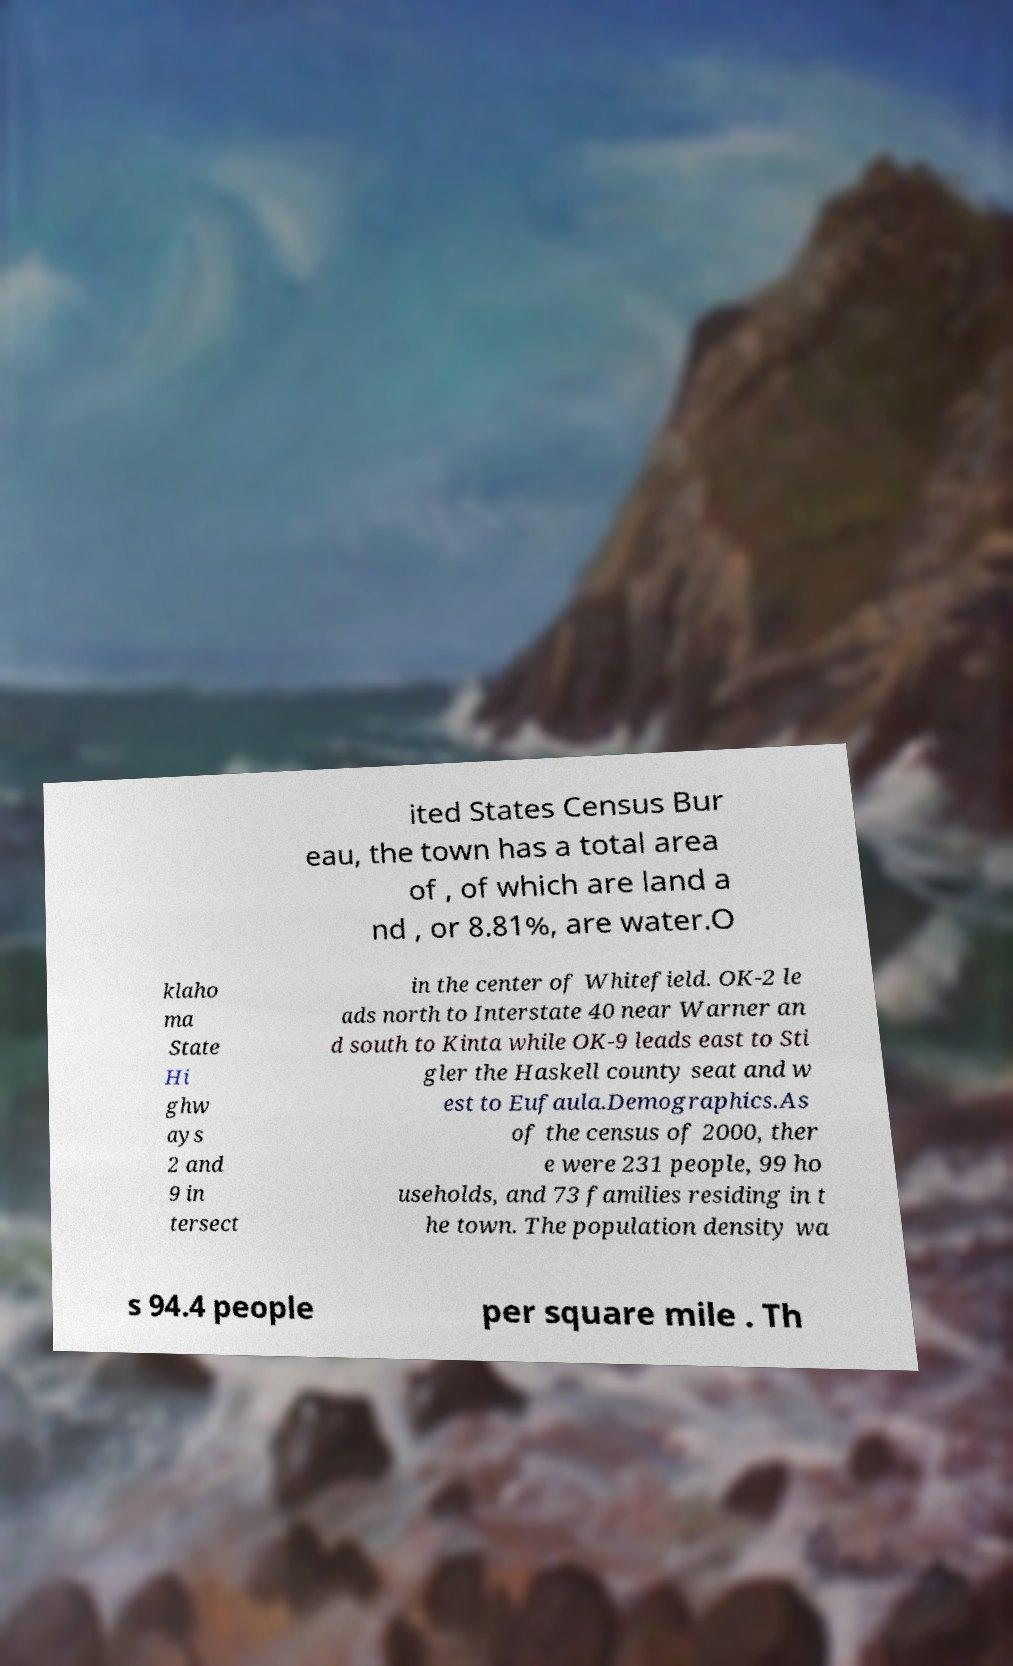There's text embedded in this image that I need extracted. Can you transcribe it verbatim? ited States Census Bur eau, the town has a total area of , of which are land a nd , or 8.81%, are water.O klaho ma State Hi ghw ays 2 and 9 in tersect in the center of Whitefield. OK-2 le ads north to Interstate 40 near Warner an d south to Kinta while OK-9 leads east to Sti gler the Haskell county seat and w est to Eufaula.Demographics.As of the census of 2000, ther e were 231 people, 99 ho useholds, and 73 families residing in t he town. The population density wa s 94.4 people per square mile . Th 